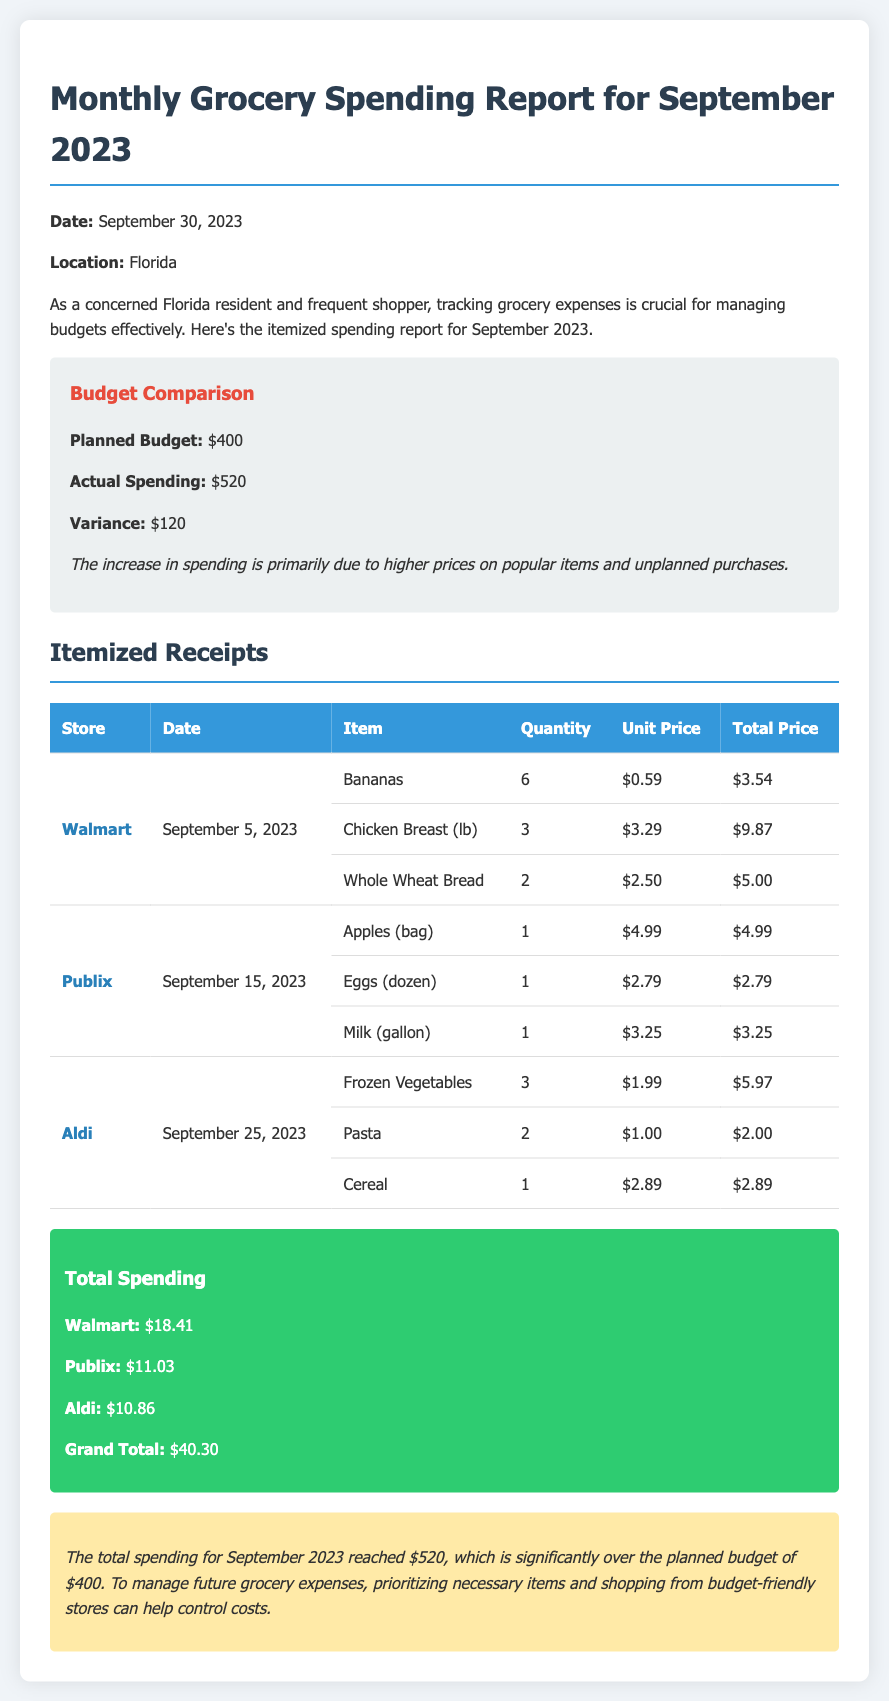What was the planned budget for September 2023? The document states that the planned budget for September 2023 was $400.
Answer: $400 What is the actual spending for September 2023? The actual spending recorded for September 2023 is $520.
Answer: $520 Which store had the highest total spending? By comparing the spending listed, Walmart had the highest total spending of $18.41.
Answer: Walmart How much did the groceries from Aldi cost in total? The total cost for groceries from Aldi is listed as $10.86.
Answer: $10.86 What is the variance between planned budget and actual spending? The variance is calculated as the actual spending minus the planned budget, resulting in $120.
Answer: $120 When did the shopping at Publix take place? The shopping at Publix occurred on September 15, 2023.
Answer: September 15, 2023 What was the total price for the chicken breast purchased? The total price for chicken breast purchased was $9.87.
Answer: $9.87 How many bananas were bought? The document indicates that 6 bananas were purchased.
Answer: 6 What is suggested to control future grocery expenses? The document suggests prioritizing necessary items and shopping from budget-friendly stores.
Answer: Prioritizing necessary items and shopping from budget-friendly stores 